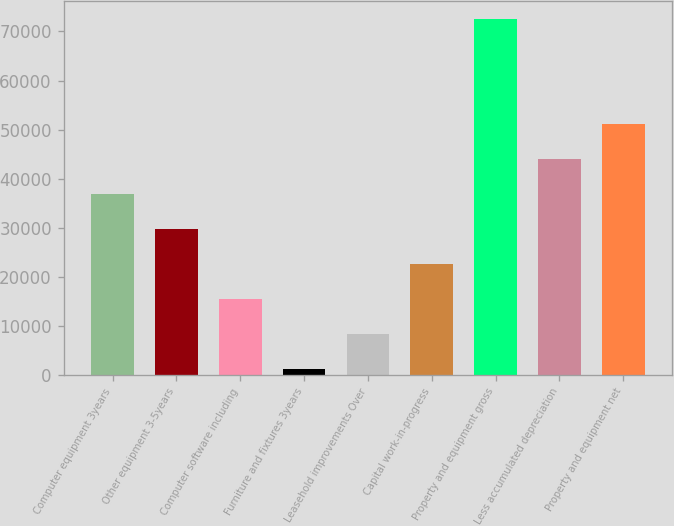<chart> <loc_0><loc_0><loc_500><loc_500><bar_chart><fcel>Computer equipment 3years<fcel>Other equipment 3-5years<fcel>Computer software including<fcel>Furniture and fixtures 3years<fcel>Leasehold improvements Over<fcel>Capital work-in-progress<fcel>Property and equipment gross<fcel>Less accumulated depreciation<fcel>Property and equipment net<nl><fcel>36931.5<fcel>29793.2<fcel>15516.6<fcel>1240<fcel>8378.3<fcel>22654.9<fcel>72623<fcel>44069.8<fcel>51208.1<nl></chart> 